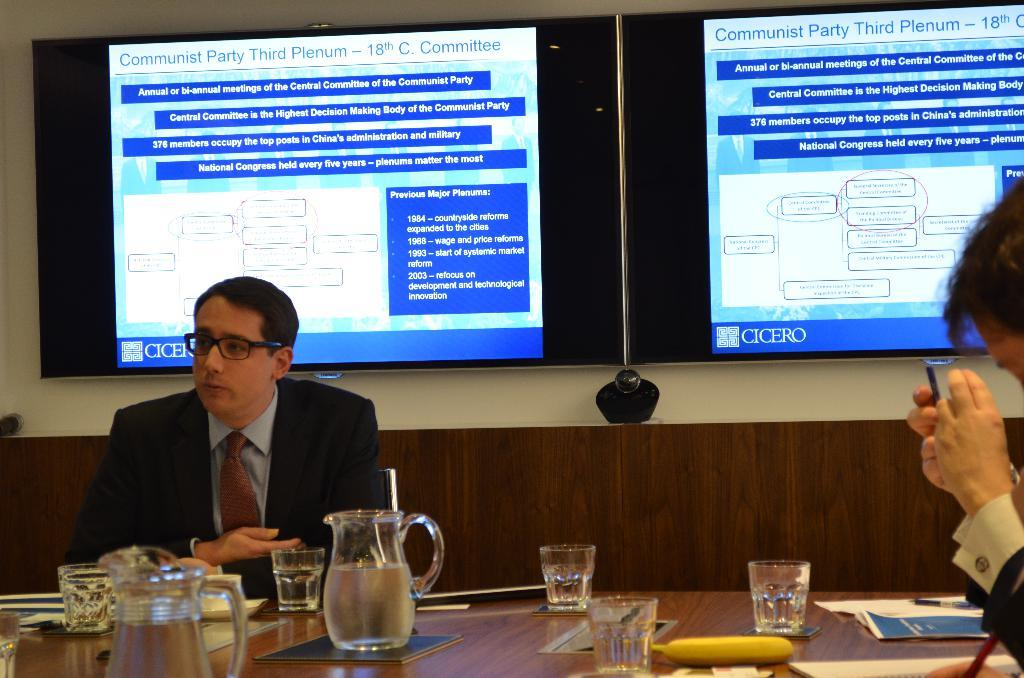Provide a one-sentence caption for the provided image. People sitting at a table under a sign that has Communist party displayed. 